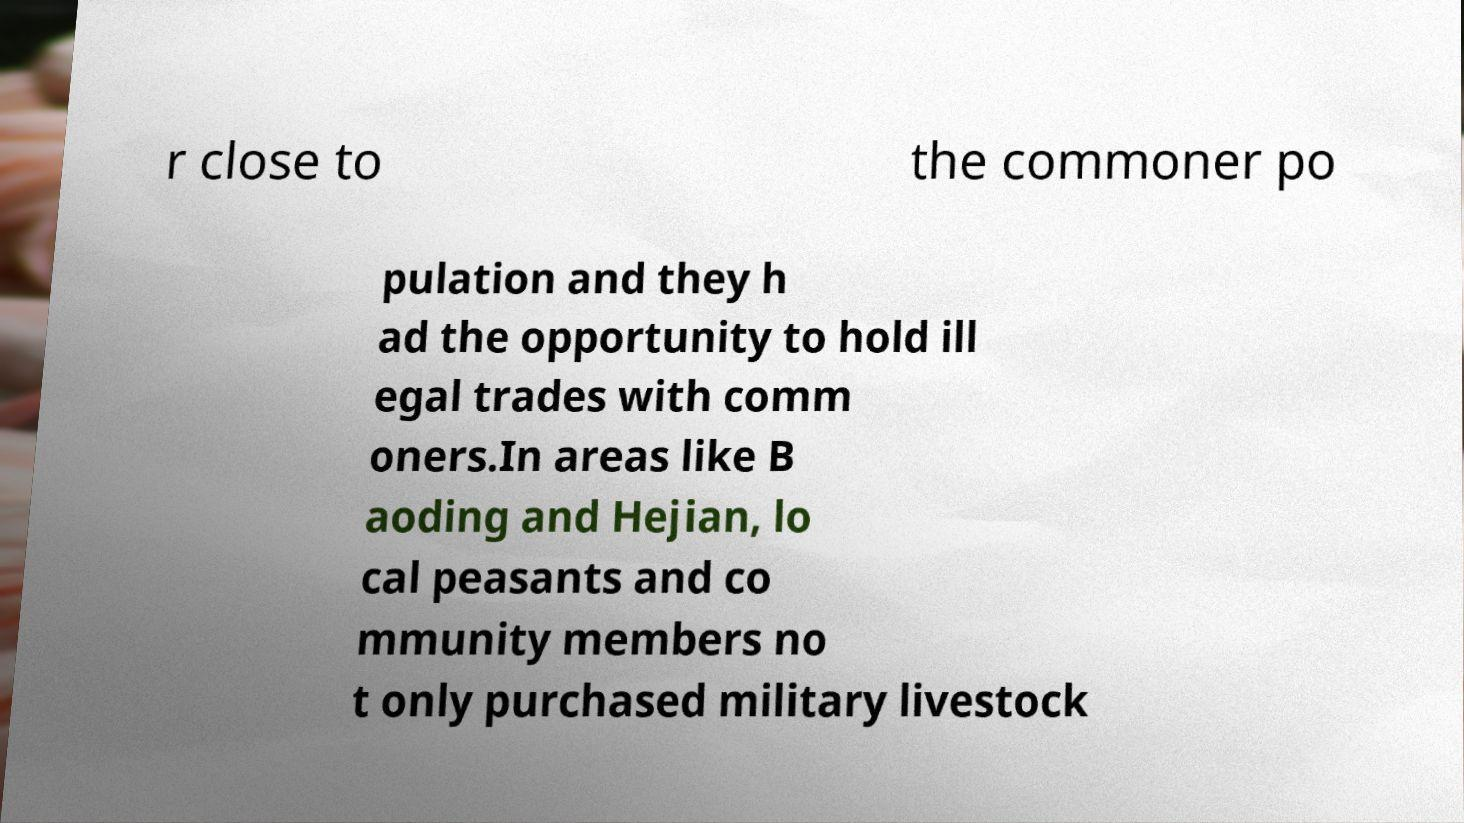Could you extract and type out the text from this image? r close to the commoner po pulation and they h ad the opportunity to hold ill egal trades with comm oners.In areas like B aoding and Hejian, lo cal peasants and co mmunity members no t only purchased military livestock 